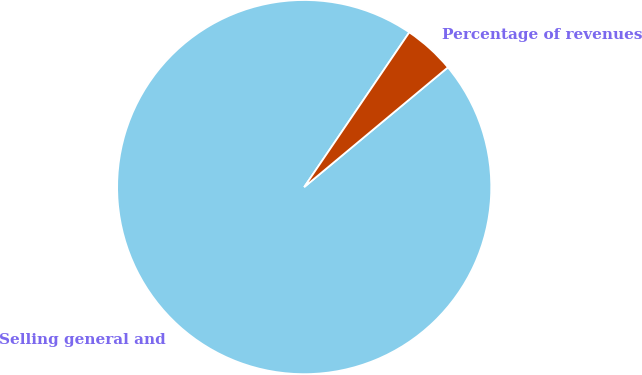Convert chart to OTSL. <chart><loc_0><loc_0><loc_500><loc_500><pie_chart><fcel>Selling general and<fcel>Percentage of revenues<nl><fcel>95.55%<fcel>4.45%<nl></chart> 